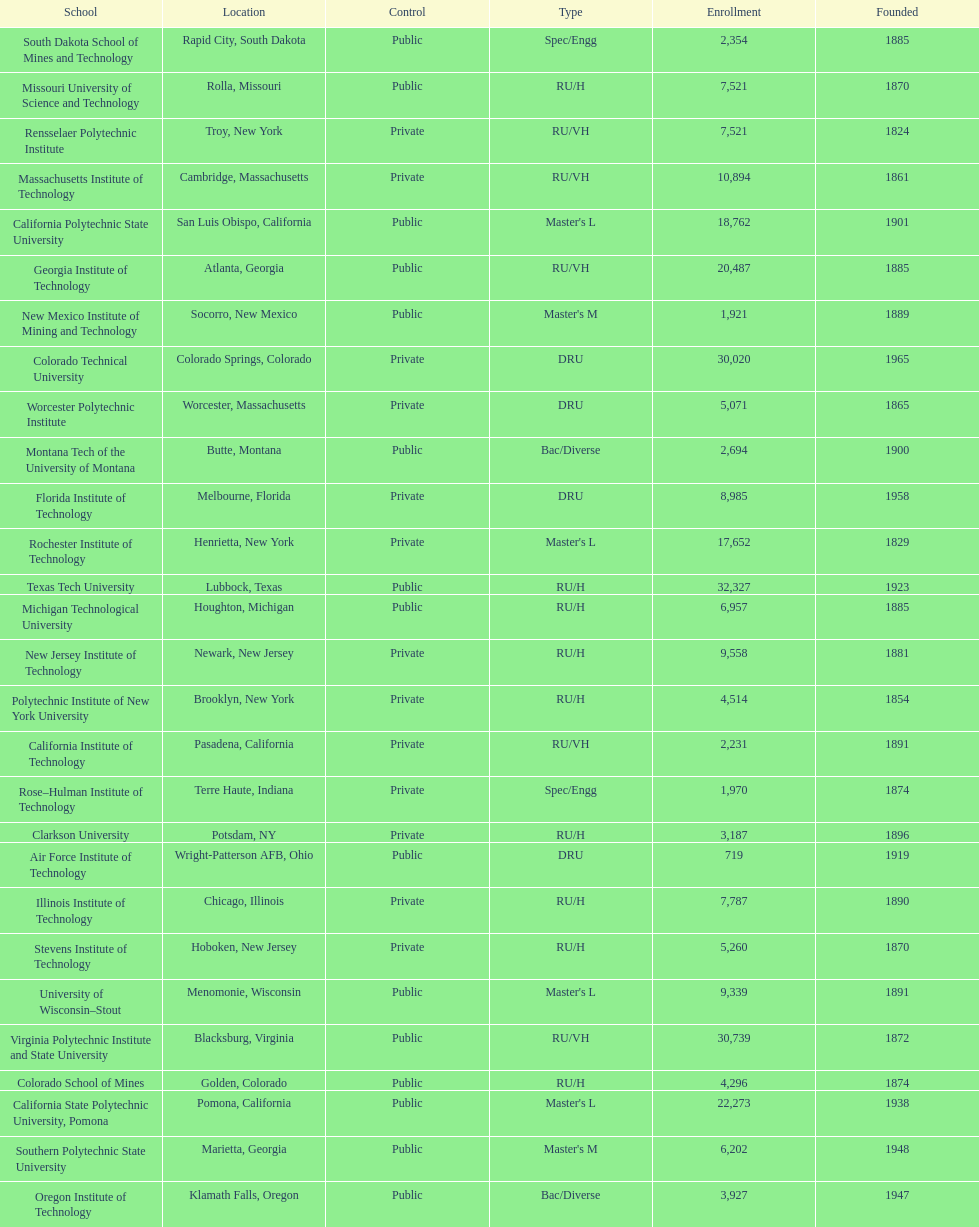Which school had the largest enrollment? Texas Tech University. 